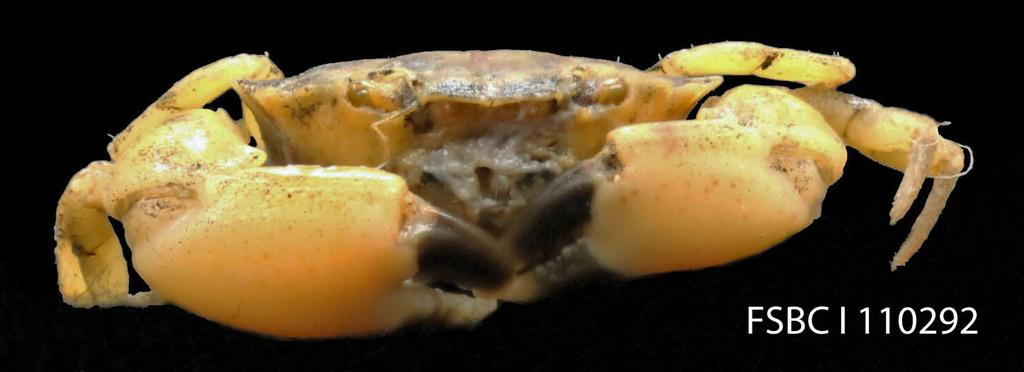What type of animal is in the image? There is a fiddler crab in the image. What color is the fiddler crab? The fiddler crab is yellow. What can be seen on the right side of the image? There are white letters and numbers on the right side of the image. What is the background of the image like? The background of the image is completely dark. What type of poison is the fiddler crab using to protect itself in the image? There is no indication of poison in the image; the fiddler crab is simply a yellow crab. What kind of board is the fiddler crab standing on in the image? There is no board present in the image; the fiddler crab is on a dark background. 